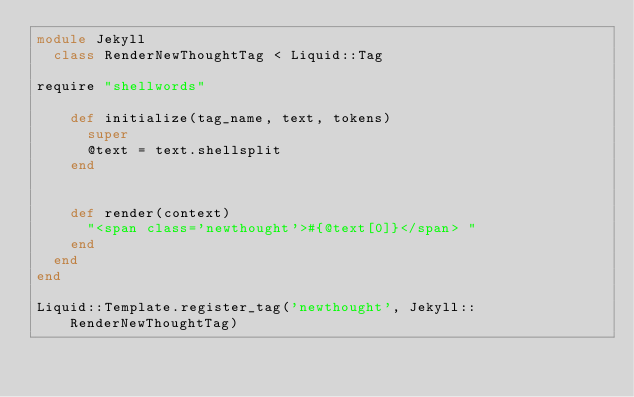Convert code to text. <code><loc_0><loc_0><loc_500><loc_500><_Ruby_>module Jekyll
  class RenderNewThoughtTag < Liquid::Tag

require "shellwords"

    def initialize(tag_name, text, tokens)
      super
      @text = text.shellsplit
    end


    def render(context)
      "<span class='newthought'>#{@text[0]}</span> "
    end
  end
end

Liquid::Template.register_tag('newthought', Jekyll::RenderNewThoughtTag)
</code> 